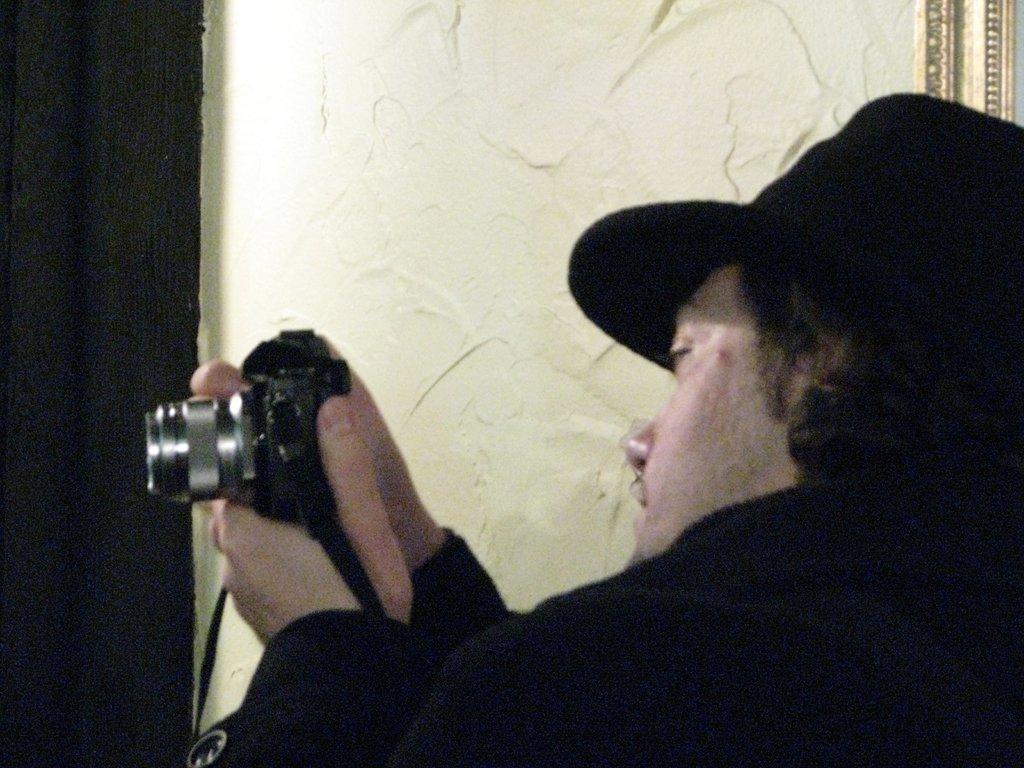Could you give a brief overview of what you see in this image? In this picture we can see a man wearing a black colour jacket and a hat, holding a camera in his hands and recording. At the left side of the picture we can see a black colour curtain. This is a wall. 